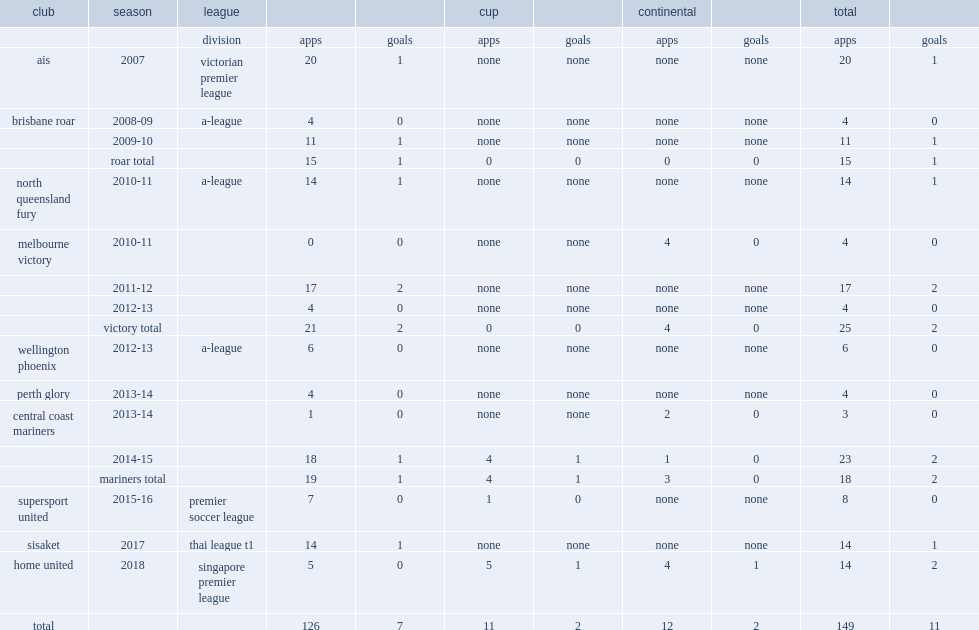Which club did isaka cernak play for in 2018? Home united. 